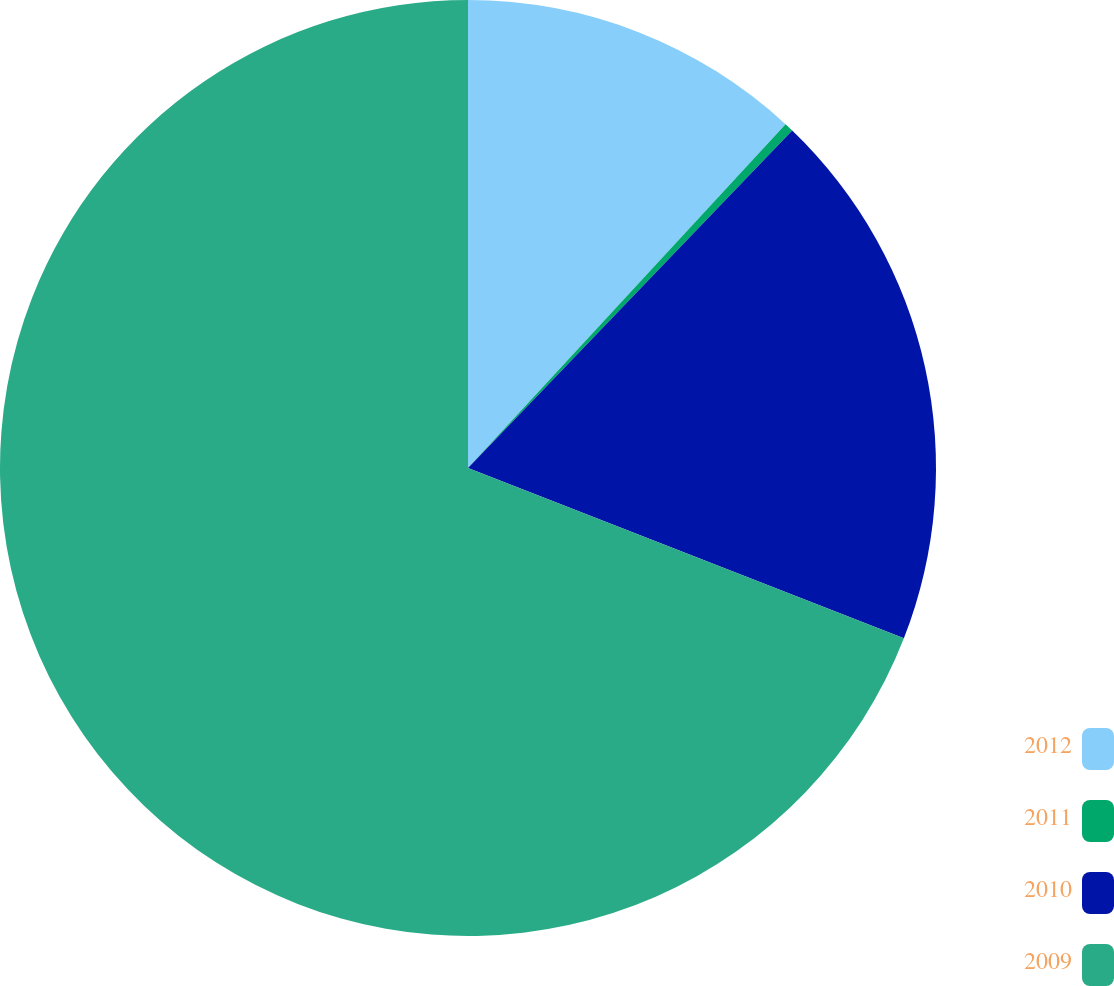<chart> <loc_0><loc_0><loc_500><loc_500><pie_chart><fcel>2012<fcel>2011<fcel>2010<fcel>2009<nl><fcel>11.87%<fcel>0.31%<fcel>18.75%<fcel>69.07%<nl></chart> 